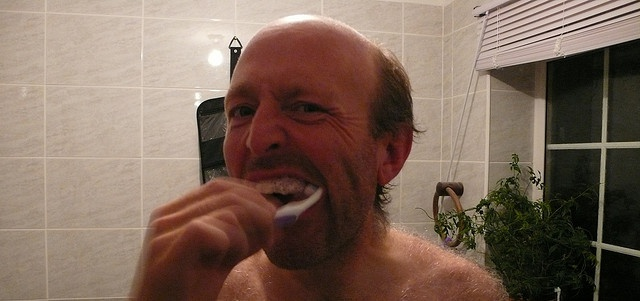Describe the objects in this image and their specific colors. I can see people in darkgray, maroon, black, and brown tones, potted plant in darkgray, black, gray, and darkgreen tones, and toothbrush in darkgray, gray, and maroon tones in this image. 